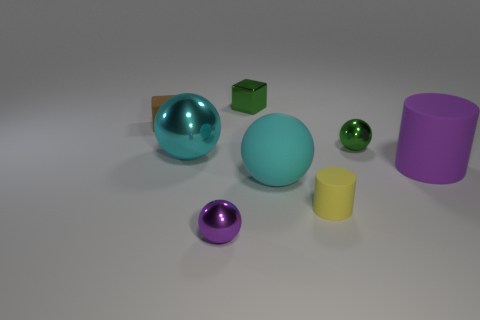Add 2 purple rubber cylinders. How many objects exist? 10 Subtract all blocks. How many objects are left? 6 Add 1 green things. How many green things are left? 3 Add 4 large spheres. How many large spheres exist? 6 Subtract 0 blue cylinders. How many objects are left? 8 Subtract all purple matte objects. Subtract all large brown matte blocks. How many objects are left? 7 